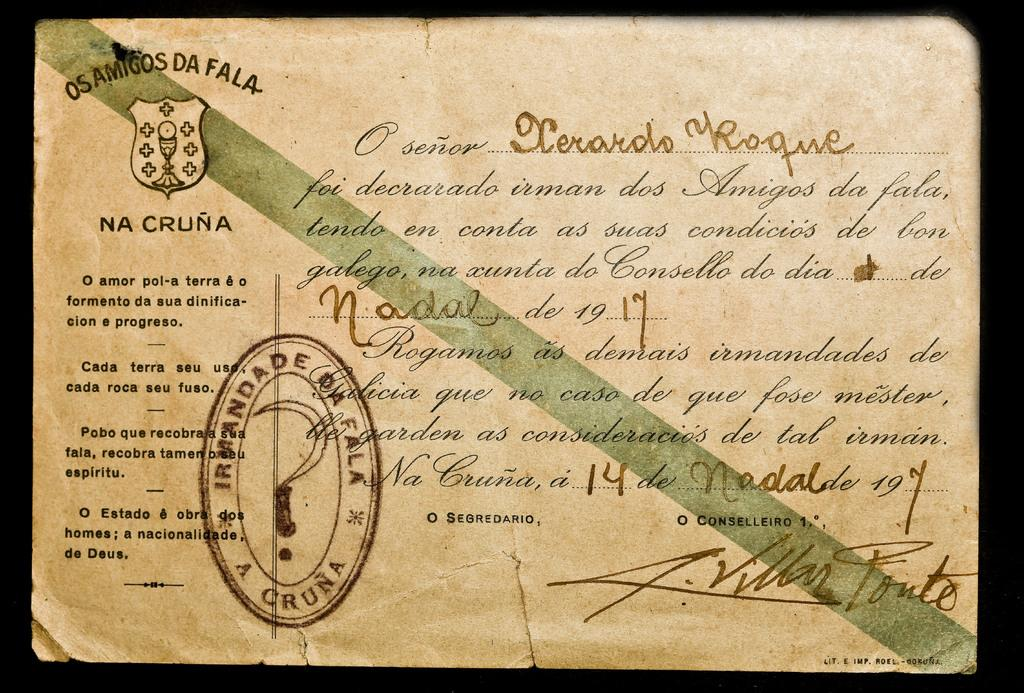What is the main object in the image? There is a certificate in the image. What can be found on the certificate? The certificate contains text and a logo. Is there any official mark on the certificate? Yes, there is a stamp on the certificate. What color is the chalk used to write on the certificate? There is no chalk present on the certificate in the image. How does the certificate express anger? The certificate does not express anger; it is a formal document with text, a logo, and a stamp. 